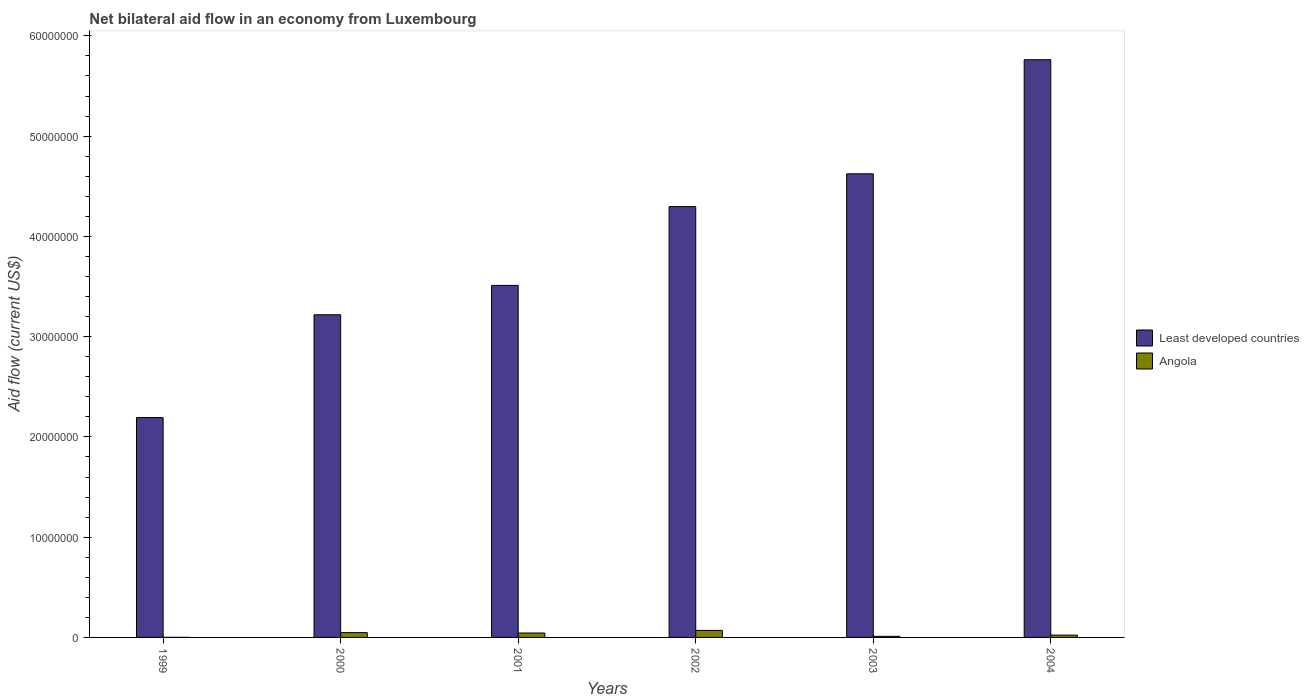How many different coloured bars are there?
Offer a very short reply. 2. How many bars are there on the 6th tick from the right?
Give a very brief answer. 2. What is the label of the 4th group of bars from the left?
Your answer should be very brief. 2002. In how many cases, is the number of bars for a given year not equal to the number of legend labels?
Your answer should be very brief. 0. What is the net bilateral aid flow in Least developed countries in 2001?
Provide a short and direct response. 3.51e+07. Across all years, what is the maximum net bilateral aid flow in Least developed countries?
Your answer should be very brief. 5.76e+07. Across all years, what is the minimum net bilateral aid flow in Angola?
Provide a succinct answer. 10000. In which year was the net bilateral aid flow in Angola maximum?
Provide a succinct answer. 2002. What is the total net bilateral aid flow in Angola in the graph?
Make the answer very short. 1.97e+06. What is the difference between the net bilateral aid flow in Least developed countries in 2001 and that in 2004?
Provide a short and direct response. -2.25e+07. What is the difference between the net bilateral aid flow in Angola in 2003 and the net bilateral aid flow in Least developed countries in 2002?
Give a very brief answer. -4.29e+07. What is the average net bilateral aid flow in Angola per year?
Provide a succinct answer. 3.28e+05. In the year 2002, what is the difference between the net bilateral aid flow in Angola and net bilateral aid flow in Least developed countries?
Your response must be concise. -4.23e+07. What is the ratio of the net bilateral aid flow in Angola in 2002 to that in 2003?
Your answer should be very brief. 6.36. Is the net bilateral aid flow in Least developed countries in 2001 less than that in 2003?
Your response must be concise. Yes. What is the difference between the highest and the lowest net bilateral aid flow in Angola?
Provide a short and direct response. 6.90e+05. In how many years, is the net bilateral aid flow in Least developed countries greater than the average net bilateral aid flow in Least developed countries taken over all years?
Keep it short and to the point. 3. Is the sum of the net bilateral aid flow in Least developed countries in 2003 and 2004 greater than the maximum net bilateral aid flow in Angola across all years?
Provide a short and direct response. Yes. What does the 1st bar from the left in 2001 represents?
Ensure brevity in your answer.  Least developed countries. What does the 2nd bar from the right in 2003 represents?
Make the answer very short. Least developed countries. How many bars are there?
Your answer should be compact. 12. How many years are there in the graph?
Offer a terse response. 6. What is the difference between two consecutive major ticks on the Y-axis?
Ensure brevity in your answer.  1.00e+07. Does the graph contain grids?
Make the answer very short. No. Where does the legend appear in the graph?
Make the answer very short. Center right. What is the title of the graph?
Provide a succinct answer. Net bilateral aid flow in an economy from Luxembourg. Does "High income: nonOECD" appear as one of the legend labels in the graph?
Keep it short and to the point. No. What is the label or title of the X-axis?
Your response must be concise. Years. What is the Aid flow (current US$) of Least developed countries in 1999?
Provide a succinct answer. 2.19e+07. What is the Aid flow (current US$) in Least developed countries in 2000?
Ensure brevity in your answer.  3.22e+07. What is the Aid flow (current US$) of Least developed countries in 2001?
Your response must be concise. 3.51e+07. What is the Aid flow (current US$) of Angola in 2001?
Your answer should be compact. 4.40e+05. What is the Aid flow (current US$) in Least developed countries in 2002?
Provide a succinct answer. 4.30e+07. What is the Aid flow (current US$) in Least developed countries in 2003?
Keep it short and to the point. 4.62e+07. What is the Aid flow (current US$) of Angola in 2003?
Your response must be concise. 1.10e+05. What is the Aid flow (current US$) in Least developed countries in 2004?
Your answer should be very brief. 5.76e+07. What is the Aid flow (current US$) of Angola in 2004?
Provide a succinct answer. 2.30e+05. Across all years, what is the maximum Aid flow (current US$) in Least developed countries?
Offer a very short reply. 5.76e+07. Across all years, what is the minimum Aid flow (current US$) in Least developed countries?
Ensure brevity in your answer.  2.19e+07. Across all years, what is the minimum Aid flow (current US$) of Angola?
Provide a short and direct response. 10000. What is the total Aid flow (current US$) of Least developed countries in the graph?
Give a very brief answer. 2.36e+08. What is the total Aid flow (current US$) in Angola in the graph?
Make the answer very short. 1.97e+06. What is the difference between the Aid flow (current US$) of Least developed countries in 1999 and that in 2000?
Your answer should be compact. -1.02e+07. What is the difference between the Aid flow (current US$) in Angola in 1999 and that in 2000?
Offer a very short reply. -4.70e+05. What is the difference between the Aid flow (current US$) of Least developed countries in 1999 and that in 2001?
Your answer should be very brief. -1.32e+07. What is the difference between the Aid flow (current US$) in Angola in 1999 and that in 2001?
Offer a very short reply. -4.30e+05. What is the difference between the Aid flow (current US$) in Least developed countries in 1999 and that in 2002?
Offer a very short reply. -2.10e+07. What is the difference between the Aid flow (current US$) of Angola in 1999 and that in 2002?
Provide a short and direct response. -6.90e+05. What is the difference between the Aid flow (current US$) in Least developed countries in 1999 and that in 2003?
Provide a short and direct response. -2.43e+07. What is the difference between the Aid flow (current US$) in Least developed countries in 1999 and that in 2004?
Ensure brevity in your answer.  -3.57e+07. What is the difference between the Aid flow (current US$) in Angola in 1999 and that in 2004?
Offer a terse response. -2.20e+05. What is the difference between the Aid flow (current US$) in Least developed countries in 2000 and that in 2001?
Provide a short and direct response. -2.93e+06. What is the difference between the Aid flow (current US$) in Least developed countries in 2000 and that in 2002?
Provide a short and direct response. -1.08e+07. What is the difference between the Aid flow (current US$) in Least developed countries in 2000 and that in 2003?
Your answer should be very brief. -1.41e+07. What is the difference between the Aid flow (current US$) in Angola in 2000 and that in 2003?
Ensure brevity in your answer.  3.70e+05. What is the difference between the Aid flow (current US$) of Least developed countries in 2000 and that in 2004?
Offer a very short reply. -2.54e+07. What is the difference between the Aid flow (current US$) in Least developed countries in 2001 and that in 2002?
Keep it short and to the point. -7.86e+06. What is the difference between the Aid flow (current US$) of Least developed countries in 2001 and that in 2003?
Give a very brief answer. -1.11e+07. What is the difference between the Aid flow (current US$) in Angola in 2001 and that in 2003?
Keep it short and to the point. 3.30e+05. What is the difference between the Aid flow (current US$) in Least developed countries in 2001 and that in 2004?
Give a very brief answer. -2.25e+07. What is the difference between the Aid flow (current US$) of Least developed countries in 2002 and that in 2003?
Ensure brevity in your answer.  -3.27e+06. What is the difference between the Aid flow (current US$) of Angola in 2002 and that in 2003?
Your answer should be very brief. 5.90e+05. What is the difference between the Aid flow (current US$) of Least developed countries in 2002 and that in 2004?
Give a very brief answer. -1.46e+07. What is the difference between the Aid flow (current US$) of Angola in 2002 and that in 2004?
Provide a succinct answer. 4.70e+05. What is the difference between the Aid flow (current US$) in Least developed countries in 2003 and that in 2004?
Give a very brief answer. -1.14e+07. What is the difference between the Aid flow (current US$) in Angola in 2003 and that in 2004?
Provide a short and direct response. -1.20e+05. What is the difference between the Aid flow (current US$) of Least developed countries in 1999 and the Aid flow (current US$) of Angola in 2000?
Offer a terse response. 2.14e+07. What is the difference between the Aid flow (current US$) in Least developed countries in 1999 and the Aid flow (current US$) in Angola in 2001?
Make the answer very short. 2.15e+07. What is the difference between the Aid flow (current US$) of Least developed countries in 1999 and the Aid flow (current US$) of Angola in 2002?
Ensure brevity in your answer.  2.12e+07. What is the difference between the Aid flow (current US$) in Least developed countries in 1999 and the Aid flow (current US$) in Angola in 2003?
Offer a terse response. 2.18e+07. What is the difference between the Aid flow (current US$) in Least developed countries in 1999 and the Aid flow (current US$) in Angola in 2004?
Make the answer very short. 2.17e+07. What is the difference between the Aid flow (current US$) of Least developed countries in 2000 and the Aid flow (current US$) of Angola in 2001?
Your response must be concise. 3.17e+07. What is the difference between the Aid flow (current US$) in Least developed countries in 2000 and the Aid flow (current US$) in Angola in 2002?
Provide a succinct answer. 3.15e+07. What is the difference between the Aid flow (current US$) in Least developed countries in 2000 and the Aid flow (current US$) in Angola in 2003?
Offer a terse response. 3.21e+07. What is the difference between the Aid flow (current US$) in Least developed countries in 2000 and the Aid flow (current US$) in Angola in 2004?
Make the answer very short. 3.20e+07. What is the difference between the Aid flow (current US$) in Least developed countries in 2001 and the Aid flow (current US$) in Angola in 2002?
Offer a very short reply. 3.44e+07. What is the difference between the Aid flow (current US$) in Least developed countries in 2001 and the Aid flow (current US$) in Angola in 2003?
Your answer should be compact. 3.50e+07. What is the difference between the Aid flow (current US$) in Least developed countries in 2001 and the Aid flow (current US$) in Angola in 2004?
Give a very brief answer. 3.49e+07. What is the difference between the Aid flow (current US$) of Least developed countries in 2002 and the Aid flow (current US$) of Angola in 2003?
Give a very brief answer. 4.29e+07. What is the difference between the Aid flow (current US$) in Least developed countries in 2002 and the Aid flow (current US$) in Angola in 2004?
Ensure brevity in your answer.  4.27e+07. What is the difference between the Aid flow (current US$) in Least developed countries in 2003 and the Aid flow (current US$) in Angola in 2004?
Keep it short and to the point. 4.60e+07. What is the average Aid flow (current US$) in Least developed countries per year?
Your response must be concise. 3.93e+07. What is the average Aid flow (current US$) in Angola per year?
Offer a very short reply. 3.28e+05. In the year 1999, what is the difference between the Aid flow (current US$) in Least developed countries and Aid flow (current US$) in Angola?
Provide a succinct answer. 2.19e+07. In the year 2000, what is the difference between the Aid flow (current US$) of Least developed countries and Aid flow (current US$) of Angola?
Provide a succinct answer. 3.17e+07. In the year 2001, what is the difference between the Aid flow (current US$) of Least developed countries and Aid flow (current US$) of Angola?
Your response must be concise. 3.47e+07. In the year 2002, what is the difference between the Aid flow (current US$) in Least developed countries and Aid flow (current US$) in Angola?
Your answer should be very brief. 4.23e+07. In the year 2003, what is the difference between the Aid flow (current US$) in Least developed countries and Aid flow (current US$) in Angola?
Keep it short and to the point. 4.61e+07. In the year 2004, what is the difference between the Aid flow (current US$) of Least developed countries and Aid flow (current US$) of Angola?
Your response must be concise. 5.74e+07. What is the ratio of the Aid flow (current US$) of Least developed countries in 1999 to that in 2000?
Make the answer very short. 0.68. What is the ratio of the Aid flow (current US$) in Angola in 1999 to that in 2000?
Keep it short and to the point. 0.02. What is the ratio of the Aid flow (current US$) of Least developed countries in 1999 to that in 2001?
Offer a terse response. 0.62. What is the ratio of the Aid flow (current US$) of Angola in 1999 to that in 2001?
Make the answer very short. 0.02. What is the ratio of the Aid flow (current US$) of Least developed countries in 1999 to that in 2002?
Make the answer very short. 0.51. What is the ratio of the Aid flow (current US$) in Angola in 1999 to that in 2002?
Offer a very short reply. 0.01. What is the ratio of the Aid flow (current US$) in Least developed countries in 1999 to that in 2003?
Keep it short and to the point. 0.47. What is the ratio of the Aid flow (current US$) of Angola in 1999 to that in 2003?
Keep it short and to the point. 0.09. What is the ratio of the Aid flow (current US$) of Least developed countries in 1999 to that in 2004?
Your answer should be very brief. 0.38. What is the ratio of the Aid flow (current US$) of Angola in 1999 to that in 2004?
Offer a terse response. 0.04. What is the ratio of the Aid flow (current US$) of Least developed countries in 2000 to that in 2001?
Give a very brief answer. 0.92. What is the ratio of the Aid flow (current US$) of Angola in 2000 to that in 2001?
Your answer should be very brief. 1.09. What is the ratio of the Aid flow (current US$) in Least developed countries in 2000 to that in 2002?
Ensure brevity in your answer.  0.75. What is the ratio of the Aid flow (current US$) of Angola in 2000 to that in 2002?
Provide a short and direct response. 0.69. What is the ratio of the Aid flow (current US$) in Least developed countries in 2000 to that in 2003?
Keep it short and to the point. 0.7. What is the ratio of the Aid flow (current US$) of Angola in 2000 to that in 2003?
Your answer should be very brief. 4.36. What is the ratio of the Aid flow (current US$) of Least developed countries in 2000 to that in 2004?
Your answer should be compact. 0.56. What is the ratio of the Aid flow (current US$) in Angola in 2000 to that in 2004?
Give a very brief answer. 2.09. What is the ratio of the Aid flow (current US$) in Least developed countries in 2001 to that in 2002?
Your response must be concise. 0.82. What is the ratio of the Aid flow (current US$) of Angola in 2001 to that in 2002?
Your answer should be compact. 0.63. What is the ratio of the Aid flow (current US$) of Least developed countries in 2001 to that in 2003?
Your response must be concise. 0.76. What is the ratio of the Aid flow (current US$) of Angola in 2001 to that in 2003?
Ensure brevity in your answer.  4. What is the ratio of the Aid flow (current US$) of Least developed countries in 2001 to that in 2004?
Give a very brief answer. 0.61. What is the ratio of the Aid flow (current US$) of Angola in 2001 to that in 2004?
Offer a terse response. 1.91. What is the ratio of the Aid flow (current US$) in Least developed countries in 2002 to that in 2003?
Give a very brief answer. 0.93. What is the ratio of the Aid flow (current US$) in Angola in 2002 to that in 2003?
Offer a very short reply. 6.36. What is the ratio of the Aid flow (current US$) in Least developed countries in 2002 to that in 2004?
Provide a succinct answer. 0.75. What is the ratio of the Aid flow (current US$) in Angola in 2002 to that in 2004?
Offer a very short reply. 3.04. What is the ratio of the Aid flow (current US$) of Least developed countries in 2003 to that in 2004?
Keep it short and to the point. 0.8. What is the ratio of the Aid flow (current US$) in Angola in 2003 to that in 2004?
Offer a very short reply. 0.48. What is the difference between the highest and the second highest Aid flow (current US$) of Least developed countries?
Your answer should be compact. 1.14e+07. What is the difference between the highest and the second highest Aid flow (current US$) in Angola?
Keep it short and to the point. 2.20e+05. What is the difference between the highest and the lowest Aid flow (current US$) of Least developed countries?
Make the answer very short. 3.57e+07. What is the difference between the highest and the lowest Aid flow (current US$) in Angola?
Offer a terse response. 6.90e+05. 